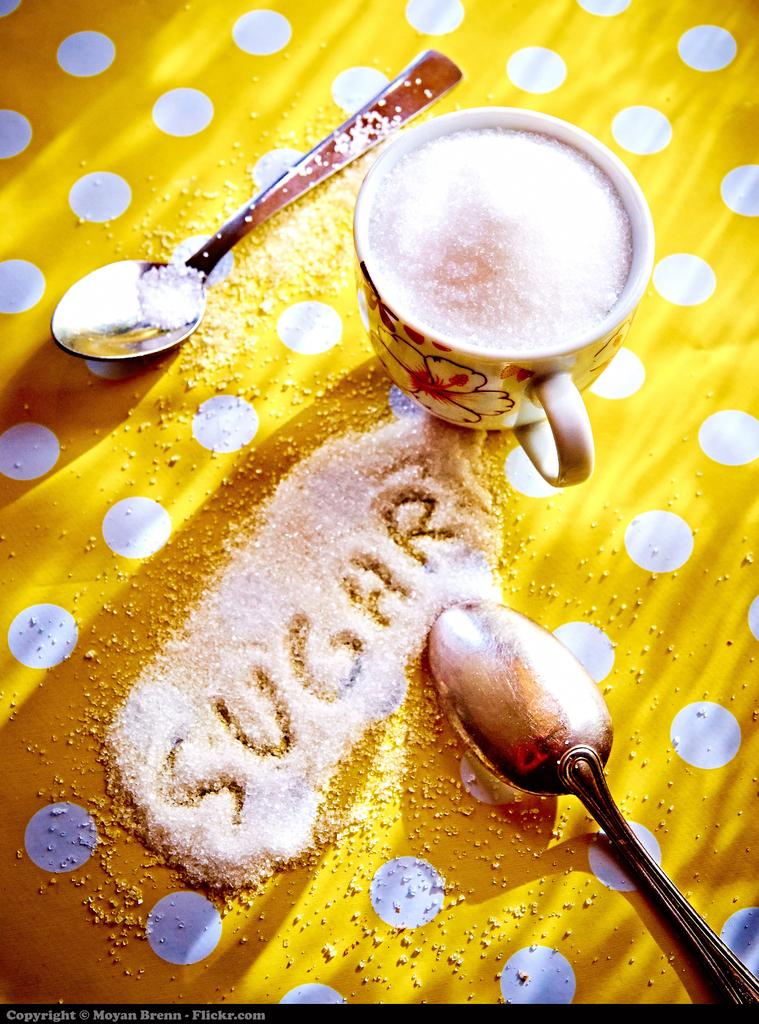How many spoons can be seen in the image? There are two spoons in the image. What is in the cup that is visible in the image? There is a cup of sugar in the image. What type of material is the cloth made of? The cloth is visible in the image. What is present on the cloth in the image? Sugar crystals are visible on the cloth. Is there a bridge visible in the image? No, there is no bridge present in the image. What type of scale is used to measure the sugar in the image? There is no scale present in the image; it only shows a cup of sugar, two spoons, and a cloth with sugar crystals. 